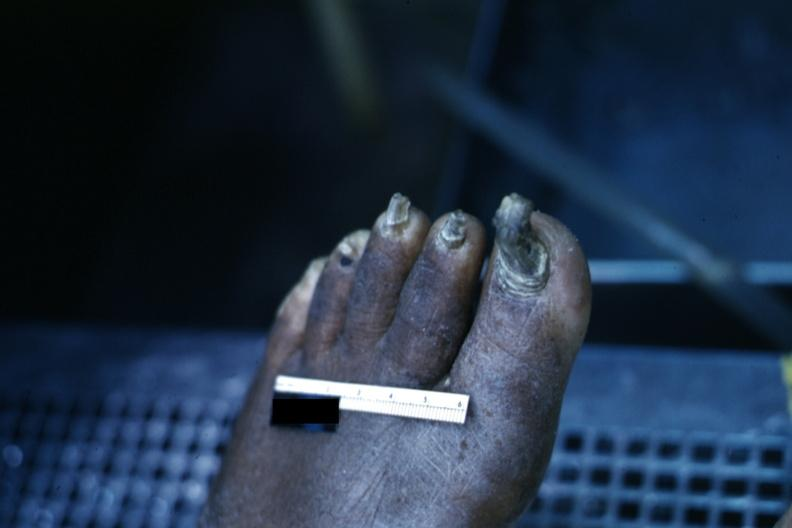does history show distorted nails and thick skin typical of chronic ischemia?
Answer the question using a single word or phrase. No 